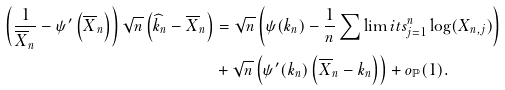<formula> <loc_0><loc_0><loc_500><loc_500>\left ( \frac { 1 } { \overline { X } _ { n } } - \psi ^ { \prime } \left ( \overline { X } _ { n } \right ) \right ) \sqrt { n } \left ( \widehat { k } _ { n } - \overline { X } _ { n } \right ) & = \sqrt { n } \left ( \psi ( k _ { n } ) - \frac { 1 } { n } \sum \lim i t s _ { j = 1 } ^ { n } \log ( X _ { n , j } ) \right ) \\ & + \sqrt { n } \left ( \psi ^ { \prime } ( k _ { n } ) \left ( \overline { X } _ { n } - k _ { n } \right ) \right ) + o _ { \mathbb { P } } ( 1 ) .</formula> 